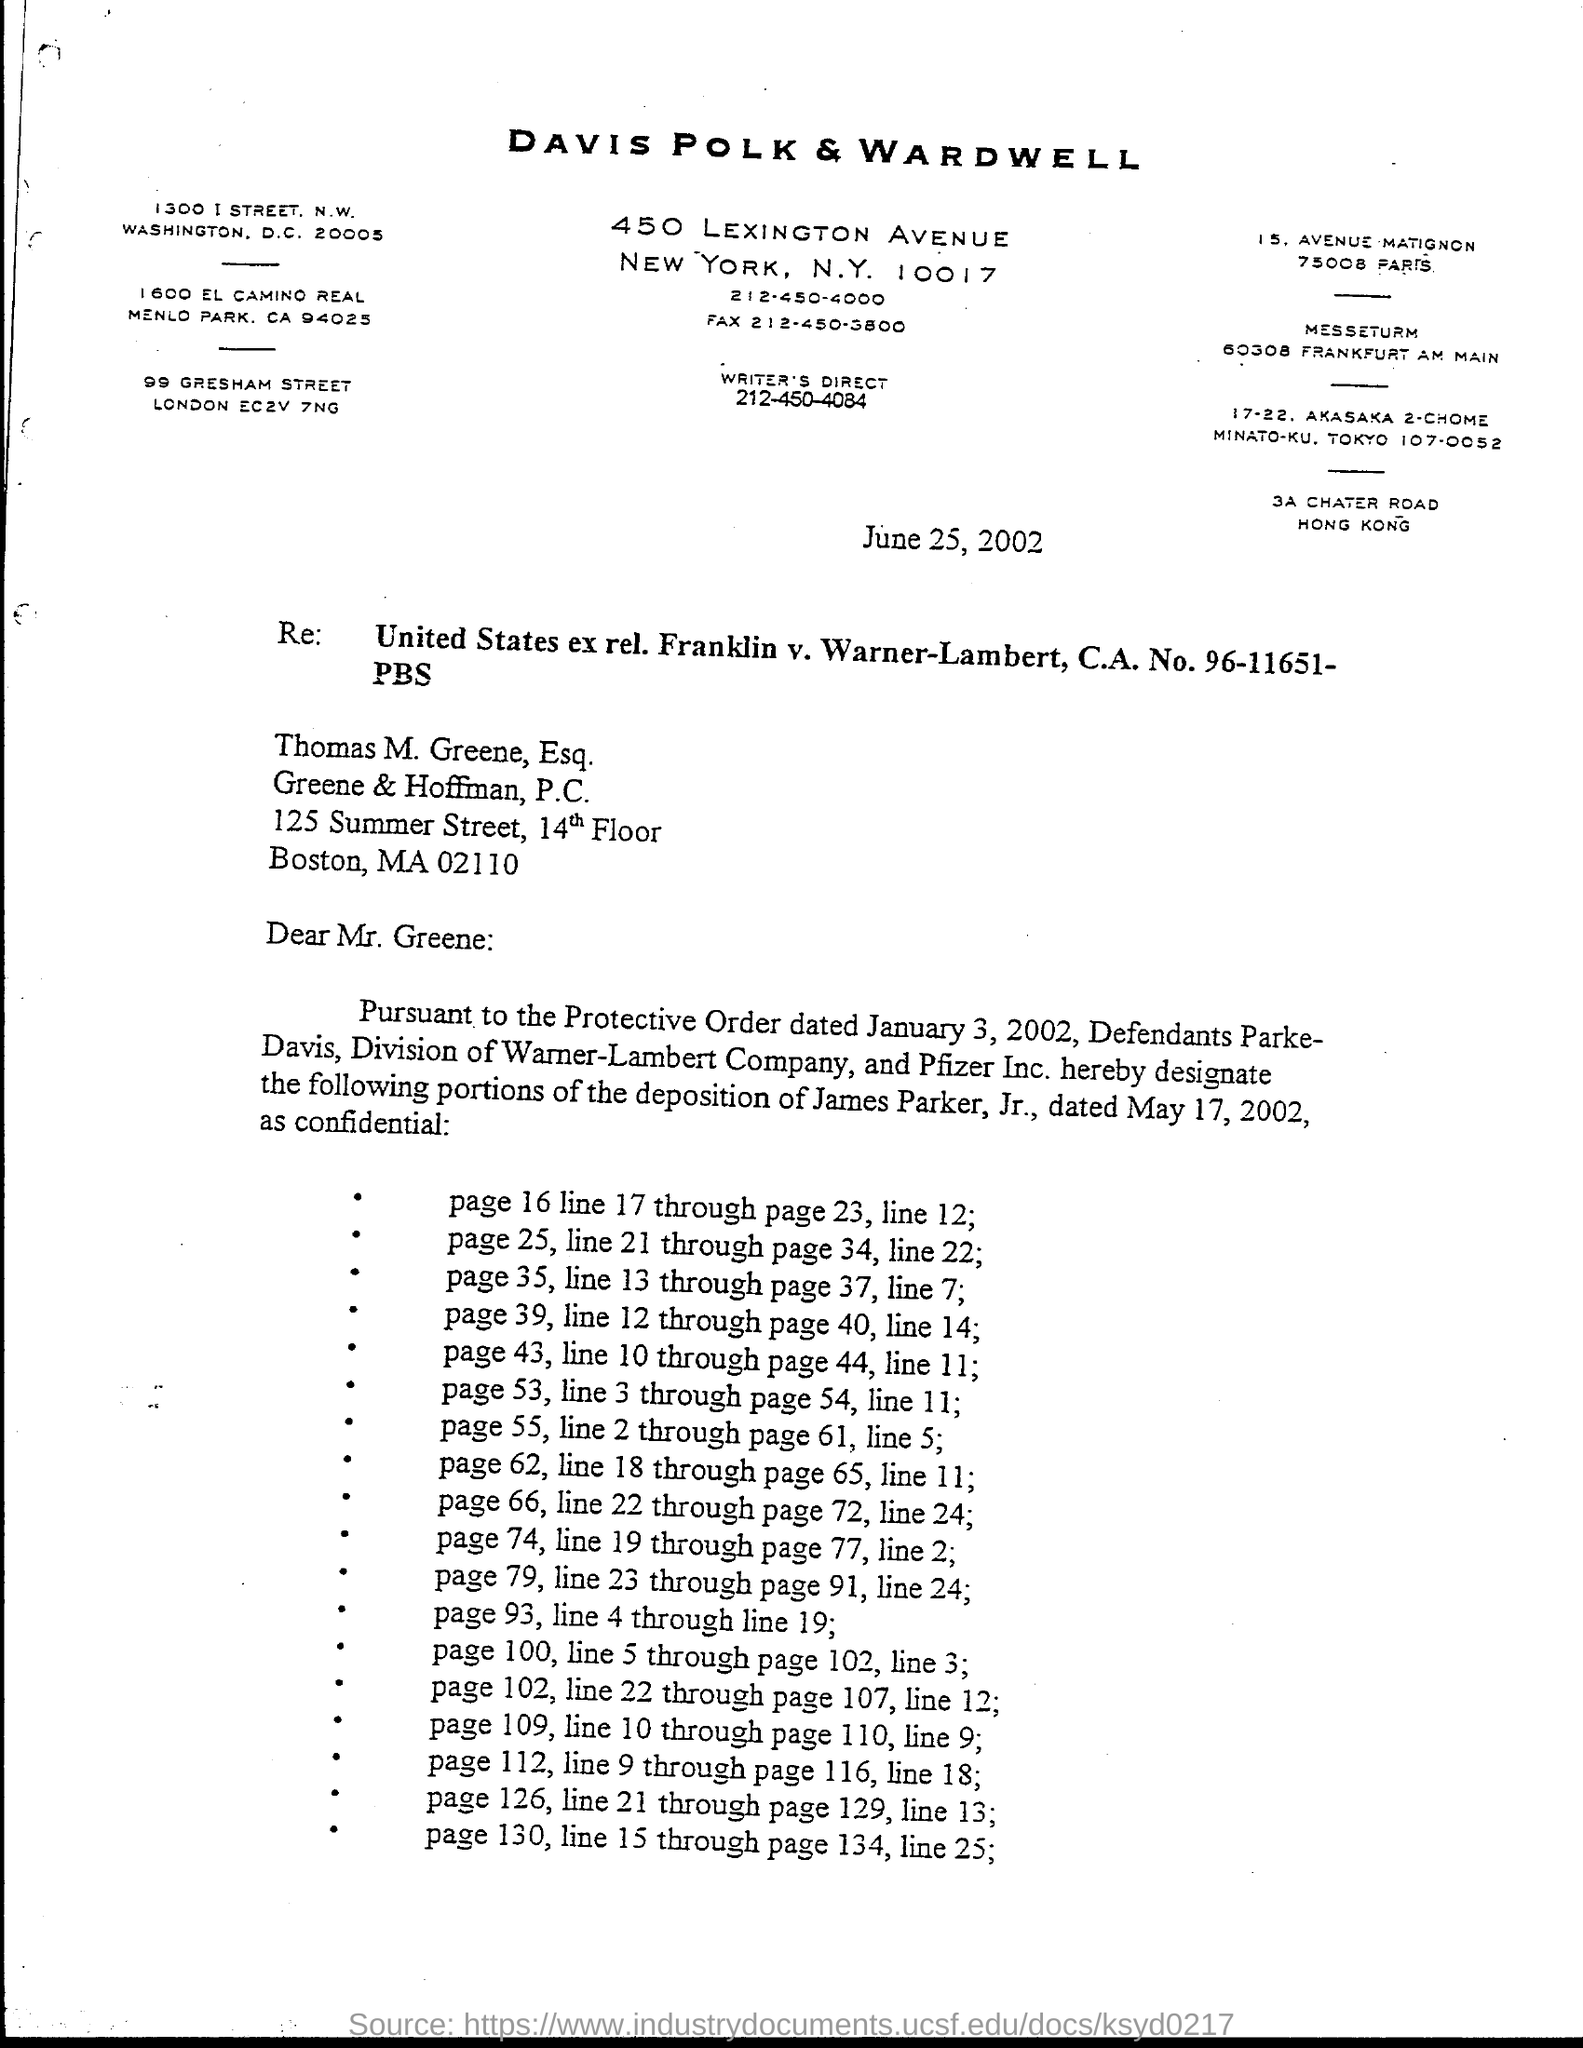Which company is mentioned in the letter head?
Your answer should be very brief. DAVIS POLK & WARDWELL. What is the issued date of this letter?
Your response must be concise. June 25, 2002. 